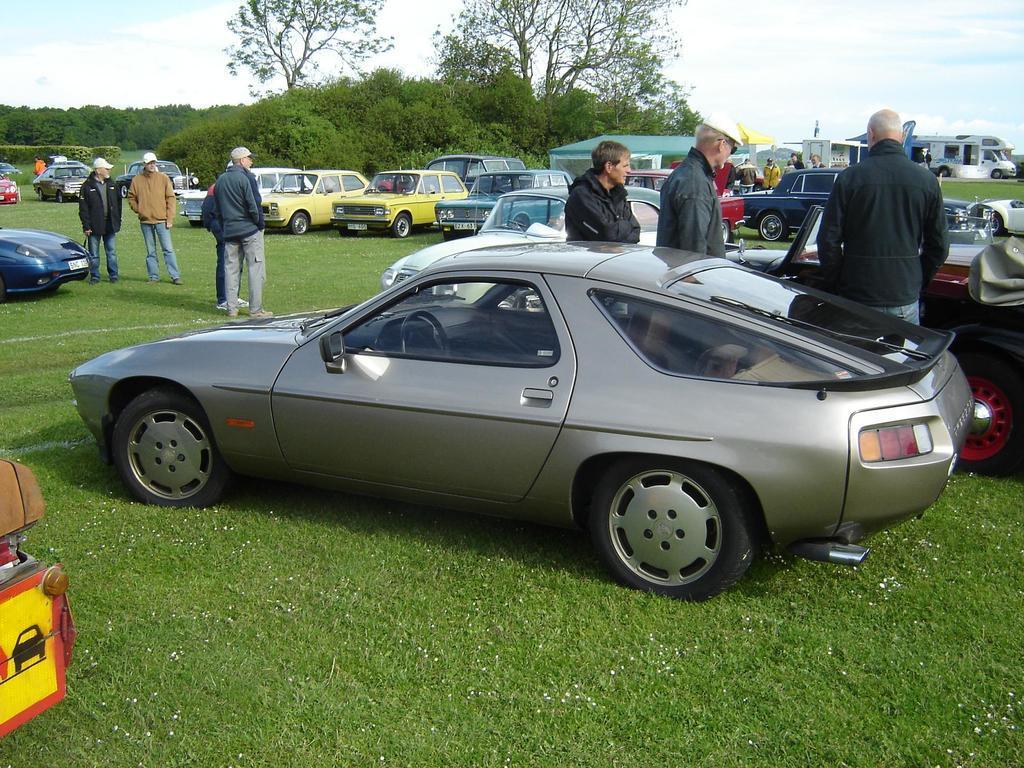Describe this image in one or two sentences. In this image, we can see people standing and there are vehicles. In the background, there are trees and at the bottom, there is ground. At the top, there is sky. 